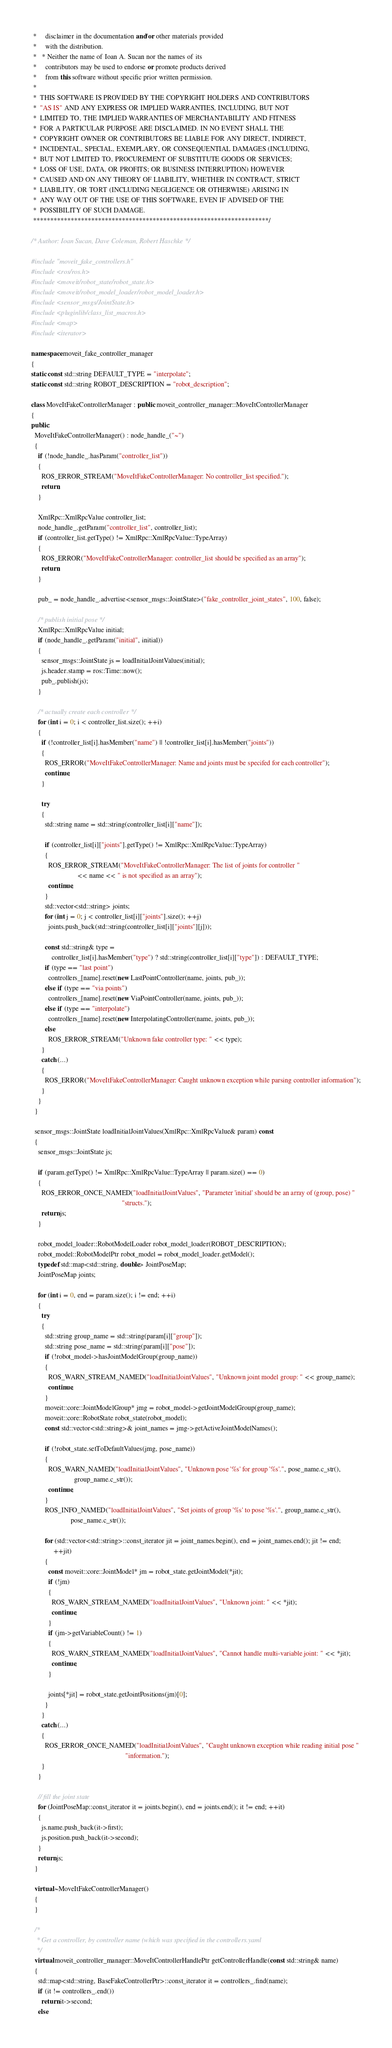<code> <loc_0><loc_0><loc_500><loc_500><_C++_> *     disclaimer in the documentation and/or other materials provided
 *     with the distribution.
 *   * Neither the name of Ioan A. Sucan nor the names of its
 *     contributors may be used to endorse or promote products derived
 *     from this software without specific prior written permission.
 *
 *  THIS SOFTWARE IS PROVIDED BY THE COPYRIGHT HOLDERS AND CONTRIBUTORS
 *  "AS IS" AND ANY EXPRESS OR IMPLIED WARRANTIES, INCLUDING, BUT NOT
 *  LIMITED TO, THE IMPLIED WARRANTIES OF MERCHANTABILITY AND FITNESS
 *  FOR A PARTICULAR PURPOSE ARE DISCLAIMED. IN NO EVENT SHALL THE
 *  COPYRIGHT OWNER OR CONTRIBUTORS BE LIABLE FOR ANY DIRECT, INDIRECT,
 *  INCIDENTAL, SPECIAL, EXEMPLARY, OR CONSEQUENTIAL DAMAGES (INCLUDING,
 *  BUT NOT LIMITED TO, PROCUREMENT OF SUBSTITUTE GOODS OR SERVICES;
 *  LOSS OF USE, DATA, OR PROFITS; OR BUSINESS INTERRUPTION) HOWEVER
 *  CAUSED AND ON ANY THEORY OF LIABILITY, WHETHER IN CONTRACT, STRICT
 *  LIABILITY, OR TORT (INCLUDING NEGLIGENCE OR OTHERWISE) ARISING IN
 *  ANY WAY OUT OF THE USE OF THIS SOFTWARE, EVEN IF ADVISED OF THE
 *  POSSIBILITY OF SUCH DAMAGE.
 *********************************************************************/

/* Author: Ioan Sucan, Dave Coleman, Robert Haschke */

#include "moveit_fake_controllers.h"
#include <ros/ros.h>
#include <moveit/robot_state/robot_state.h>
#include <moveit/robot_model_loader/robot_model_loader.h>
#include <sensor_msgs/JointState.h>
#include <pluginlib/class_list_macros.h>
#include <map>
#include <iterator>

namespace moveit_fake_controller_manager
{
static const std::string DEFAULT_TYPE = "interpolate";
static const std::string ROBOT_DESCRIPTION = "robot_description";

class MoveItFakeControllerManager : public moveit_controller_manager::MoveItControllerManager
{
public:
  MoveItFakeControllerManager() : node_handle_("~")
  {
    if (!node_handle_.hasParam("controller_list"))
    {
      ROS_ERROR_STREAM("MoveItFakeControllerManager: No controller_list specified.");
      return;
    }

    XmlRpc::XmlRpcValue controller_list;
    node_handle_.getParam("controller_list", controller_list);
    if (controller_list.getType() != XmlRpc::XmlRpcValue::TypeArray)
    {
      ROS_ERROR("MoveItFakeControllerManager: controller_list should be specified as an array");
      return;
    }

    pub_ = node_handle_.advertise<sensor_msgs::JointState>("fake_controller_joint_states", 100, false);

    /* publish initial pose */
    XmlRpc::XmlRpcValue initial;
    if (node_handle_.getParam("initial", initial))
    {
      sensor_msgs::JointState js = loadInitialJointValues(initial);
      js.header.stamp = ros::Time::now();
      pub_.publish(js);
    }

    /* actually create each controller */
    for (int i = 0; i < controller_list.size(); ++i)
    {
      if (!controller_list[i].hasMember("name") || !controller_list[i].hasMember("joints"))
      {
        ROS_ERROR("MoveItFakeControllerManager: Name and joints must be specifed for each controller");
        continue;
      }

      try
      {
        std::string name = std::string(controller_list[i]["name"]);

        if (controller_list[i]["joints"].getType() != XmlRpc::XmlRpcValue::TypeArray)
        {
          ROS_ERROR_STREAM("MoveItFakeControllerManager: The list of joints for controller "
                           << name << " is not specified as an array");
          continue;
        }
        std::vector<std::string> joints;
        for (int j = 0; j < controller_list[i]["joints"].size(); ++j)
          joints.push_back(std::string(controller_list[i]["joints"][j]));

        const std::string& type =
            controller_list[i].hasMember("type") ? std::string(controller_list[i]["type"]) : DEFAULT_TYPE;
        if (type == "last point")
          controllers_[name].reset(new LastPointController(name, joints, pub_));
        else if (type == "via points")
          controllers_[name].reset(new ViaPointController(name, joints, pub_));
        else if (type == "interpolate")
          controllers_[name].reset(new InterpolatingController(name, joints, pub_));
        else
          ROS_ERROR_STREAM("Unknown fake controller type: " << type);
      }
      catch (...)
      {
        ROS_ERROR("MoveItFakeControllerManager: Caught unknown exception while parsing controller information");
      }
    }
  }

  sensor_msgs::JointState loadInitialJointValues(XmlRpc::XmlRpcValue& param) const
  {
    sensor_msgs::JointState js;

    if (param.getType() != XmlRpc::XmlRpcValue::TypeArray || param.size() == 0)
    {
      ROS_ERROR_ONCE_NAMED("loadInitialJointValues", "Parameter 'initial' should be an array of (group, pose) "
                                                     "structs.");
      return js;
    }

    robot_model_loader::RobotModelLoader robot_model_loader(ROBOT_DESCRIPTION);
    robot_model::RobotModelPtr robot_model = robot_model_loader.getModel();
    typedef std::map<std::string, double> JointPoseMap;
    JointPoseMap joints;

    for (int i = 0, end = param.size(); i != end; ++i)
    {
      try
      {
        std::string group_name = std::string(param[i]["group"]);
        std::string pose_name = std::string(param[i]["pose"]);
        if (!robot_model->hasJointModelGroup(group_name))
        {
          ROS_WARN_STREAM_NAMED("loadInitialJointValues", "Unknown joint model group: " << group_name);
          continue;
        }
        moveit::core::JointModelGroup* jmg = robot_model->getJointModelGroup(group_name);
        moveit::core::RobotState robot_state(robot_model);
        const std::vector<std::string>& joint_names = jmg->getActiveJointModelNames();

        if (!robot_state.setToDefaultValues(jmg, pose_name))
        {
          ROS_WARN_NAMED("loadInitialJointValues", "Unknown pose '%s' for group '%s'.", pose_name.c_str(),
                         group_name.c_str());
          continue;
        }
        ROS_INFO_NAMED("loadInitialJointValues", "Set joints of group '%s' to pose '%s'.", group_name.c_str(),
                       pose_name.c_str());

        for (std::vector<std::string>::const_iterator jit = joint_names.begin(), end = joint_names.end(); jit != end;
             ++jit)
        {
          const moveit::core::JointModel* jm = robot_state.getJointModel(*jit);
          if (!jm)
          {
            ROS_WARN_STREAM_NAMED("loadInitialJointValues", "Unknown joint: " << *jit);
            continue;
          }
          if (jm->getVariableCount() != 1)
          {
            ROS_WARN_STREAM_NAMED("loadInitialJointValues", "Cannot handle multi-variable joint: " << *jit);
            continue;
          }

          joints[*jit] = robot_state.getJointPositions(jm)[0];
        }
      }
      catch (...)
      {
        ROS_ERROR_ONCE_NAMED("loadInitialJointValues", "Caught unknown exception while reading initial pose "
                                                       "information.");
      }
    }

    // fill the joint state
    for (JointPoseMap::const_iterator it = joints.begin(), end = joints.end(); it != end; ++it)
    {
      js.name.push_back(it->first);
      js.position.push_back(it->second);
    }
    return js;
  }

  virtual ~MoveItFakeControllerManager()
  {
  }

  /*
   * Get a controller, by controller name (which was specified in the controllers.yaml
   */
  virtual moveit_controller_manager::MoveItControllerHandlePtr getControllerHandle(const std::string& name)
  {
    std::map<std::string, BaseFakeControllerPtr>::const_iterator it = controllers_.find(name);
    if (it != controllers_.end())
      return it->second;
    else</code> 